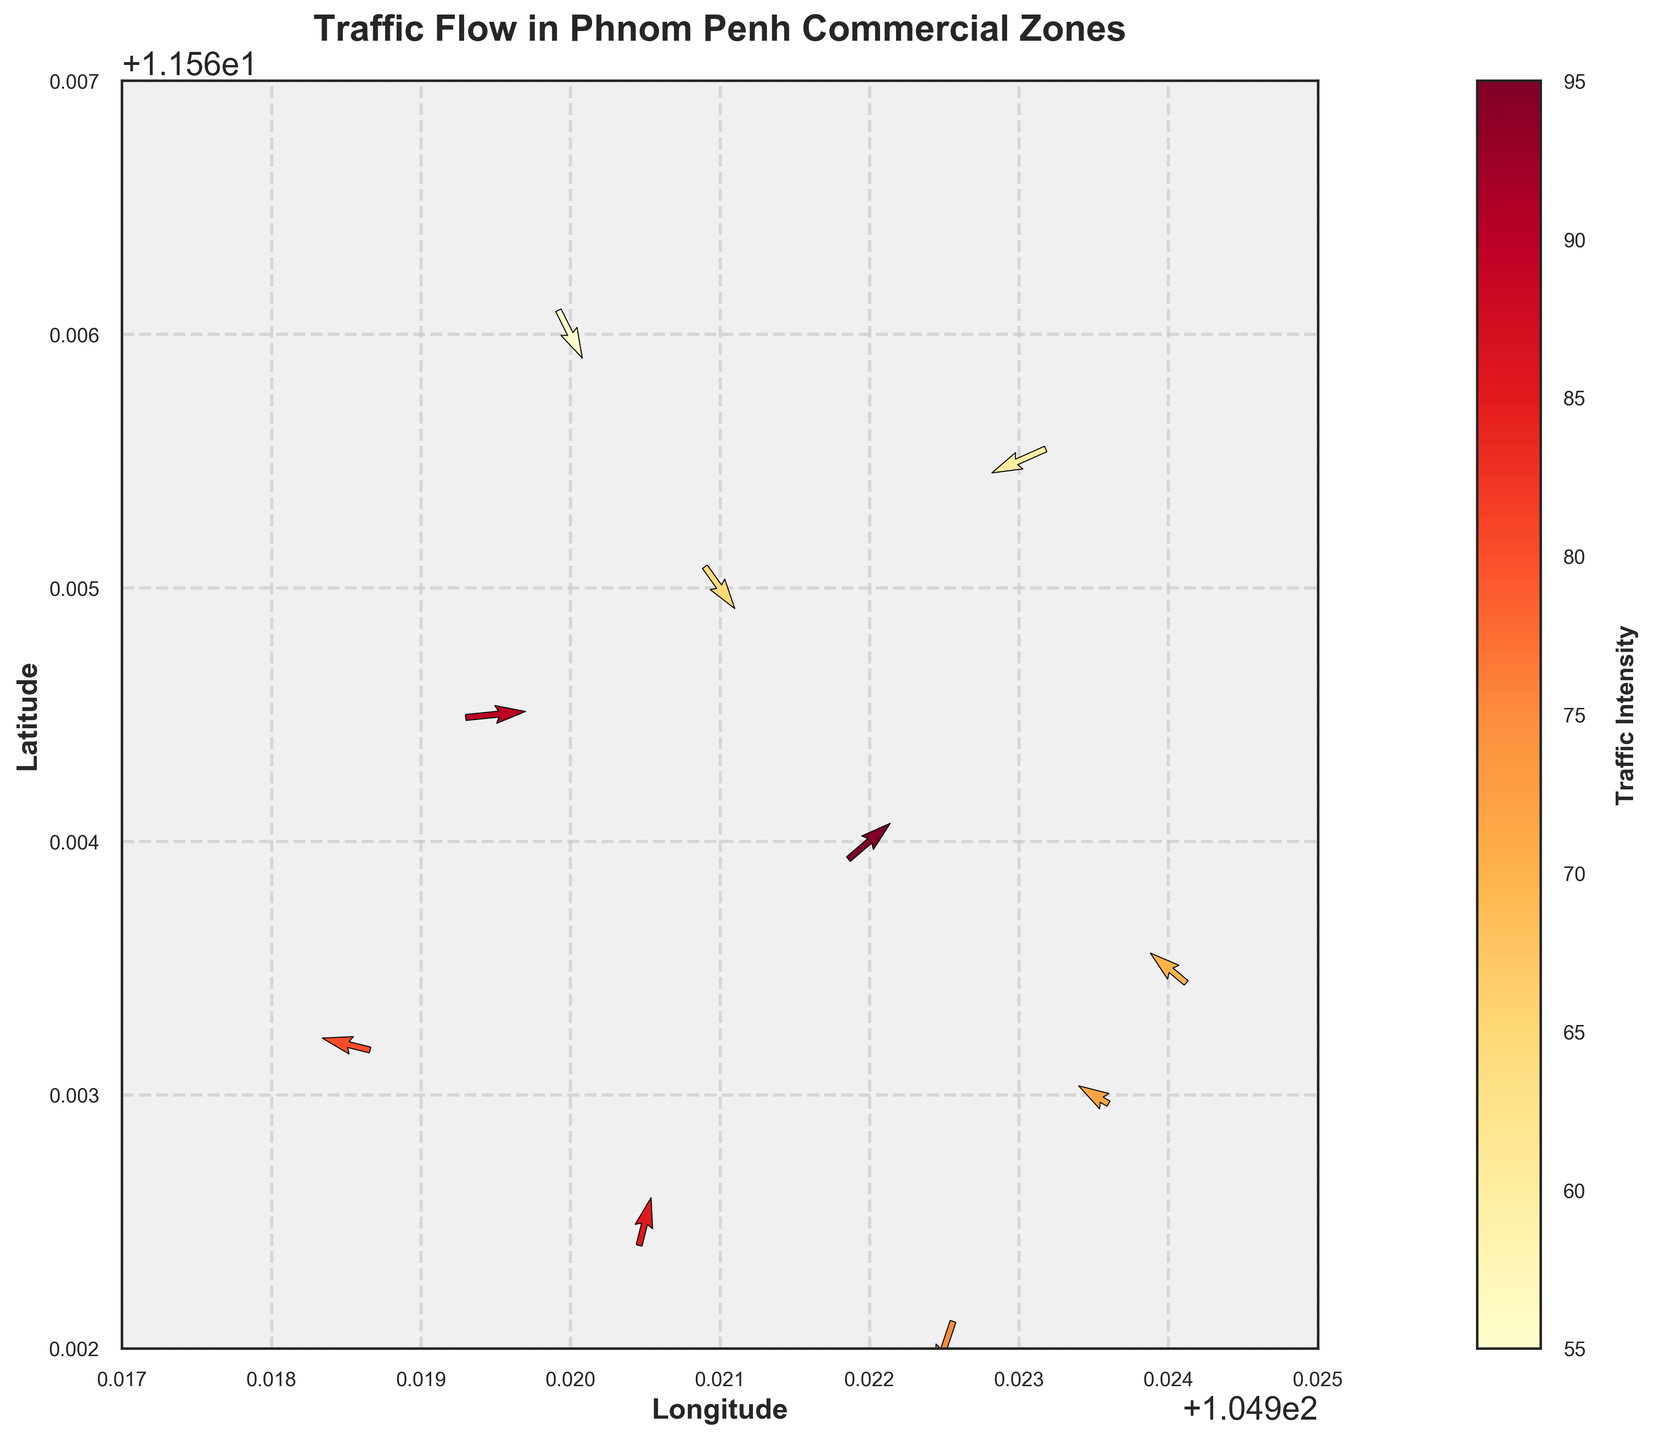What is the title of the figure? The title is displayed at the top center of the figure in bold font that describes the entire plot.
Answer: Traffic Flow in Phnom Penh Commercial Zones What do the arrows represent? The arrows in the quiver plot represent the direction and magnitude of traffic flow. The direction is indicated by the orientation of the arrows, and the intensity or magnitude is shown by the size and color of the arrows.
Answer: Traffic flow direction and magnitude How many data points are visualized in the plot? By counting the number of arrows shown in the quiver plot, we can determine the number of data points.
Answer: 10 Which data point has the highest traffic intensity? By referring to the color bar that maps colors to intensity, look for the brightest or the most color-saturated arrow in the figure. Verify with the corresponding data point.
Answer: Data point at (104.9220, 11.5640) What is the range of the color bar for traffic intensity? The color bar on the right side of the figure provides a range that the intensity values span.
Answer: 55 to 95 Which data point has an upward traffic flow direction? An upward traffic flow direction is indicated by an arrow pointing up. Identify the arrows pointing up and check the data points.
Answer: Data point at (104.9205, 11.5625) Where is the traffic flow moving diagonally downwards to the left? Such a direction is indicated by an arrow pointing from the top right to the bottom left. Look for arrows with that direction in the plot.
Answer: Data point at (104.9225, 11.5620) Compare the traffic intensity at (104.9200, 11.5660) and (104.9230, 11.5655). Which is higher? Check the colors of the arrows at these coordinates based on the color bar. The more intense color corresponds to a higher traffic intensity.
Answer: (104.9230, 11.5655) What is the general direction of traffic flow at (104.9195, 11.5645)? Observe the direction of the arrow at this point. The direction of this arrow represents the general direction of traffic flow.
Answer: Rightward On average, is the traffic intensity above or below 75? Calculate the average of all intensity values. If it's more than 75, it's above; otherwise, it's below.
Answer: Above 